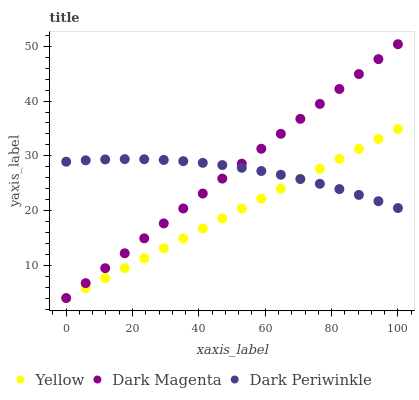Does Yellow have the minimum area under the curve?
Answer yes or no. Yes. Does Dark Magenta have the maximum area under the curve?
Answer yes or no. Yes. Does Dark Periwinkle have the minimum area under the curve?
Answer yes or no. No. Does Dark Periwinkle have the maximum area under the curve?
Answer yes or no. No. Is Dark Magenta the smoothest?
Answer yes or no. Yes. Is Dark Periwinkle the roughest?
Answer yes or no. Yes. Is Yellow the smoothest?
Answer yes or no. No. Is Yellow the roughest?
Answer yes or no. No. Does Dark Magenta have the lowest value?
Answer yes or no. Yes. Does Dark Periwinkle have the lowest value?
Answer yes or no. No. Does Dark Magenta have the highest value?
Answer yes or no. Yes. Does Yellow have the highest value?
Answer yes or no. No. Does Dark Periwinkle intersect Yellow?
Answer yes or no. Yes. Is Dark Periwinkle less than Yellow?
Answer yes or no. No. Is Dark Periwinkle greater than Yellow?
Answer yes or no. No. 